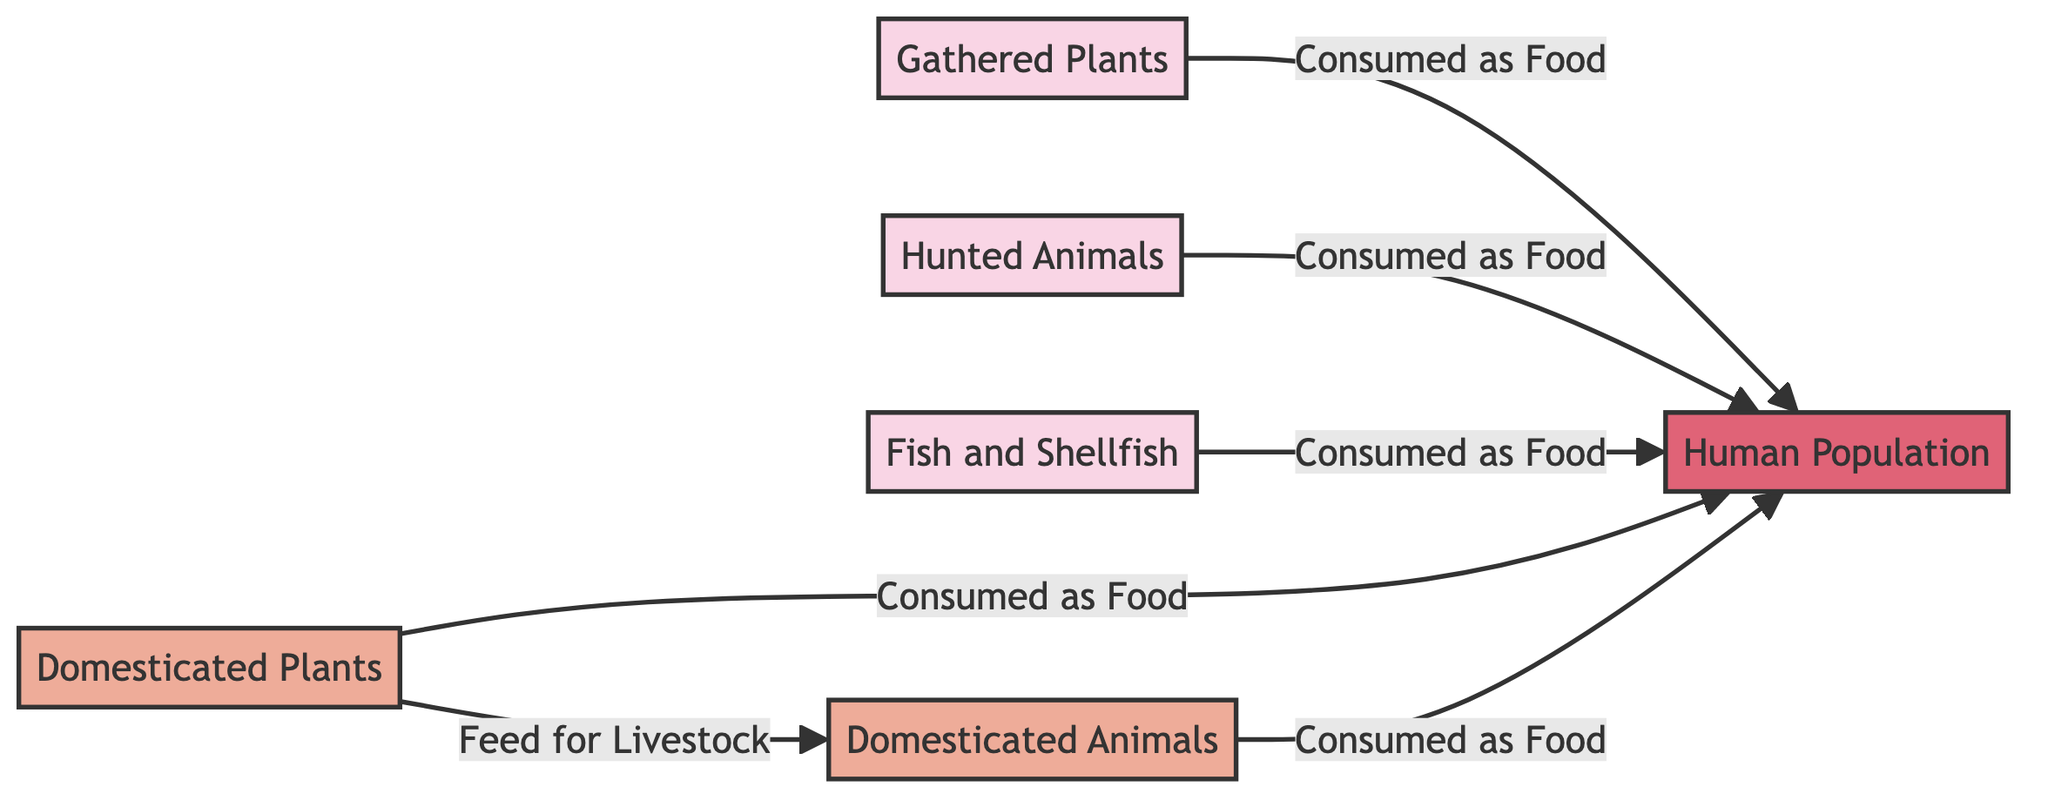What are the primary food sources for the human population? The diagram lists gathered plants, hunted animals, and fish and shellfish as the primary food sources. These are the nodes that directly feed into the human population node, indicating they are essential food sources for early humans.
Answer: gathered plants, hunted animals, fish and shellfish How many nodes are there in the diagram? The diagram has a total of six nodes: Gathered Plants, Hunted Animals, Fish and Shellfish, Domesticated Plants, Domesticated Animals, and Human Population. Each node represents a different aspect of the food chain in early human settlements.
Answer: 6 Which domesticated item is used as feed for livestock? The diagram indicates that domesticated plants serve as feed for domesticated animals, highlighting the relationship where domesticated plants contribute to the sustenance of livestock in agrarian societies.
Answer: Domesticated Plants What is the relationship between gathered plants and the human population? The relationship shown in the diagram is that gathered plants are consumed as food by the human population, highlighting how foraging contributed directly to the survival of early humans.
Answer: Consumed as Food What is the highest level in the food chain depicted in the diagram? The diagram portrays the human population as the top of the food chain, indicating that all other nodes provide food for this primary node, making it the apex predator of this early food system.
Answer: Human Population How many edges connect to the human population node? The human population node has five edges connecting to it: three from primary food sources (gathered plants, hunted animals, fish and shellfish) and two from secondary food sources (domesticated plants and domesticated animals). This indicates the diverse food intake of early humans.
Answer: 5 What color is used for the node representing hunted animals? In the diagram, hunted animals are represented in a light pinkish color, which distinguishes this category of food sources from others in the diagram.
Answer: #f9d5e5 What feeds into the domesticated animals node? The diagram shows that domesticated plants function as feed for domesticated animals, highlighting the connection between agricultural practices and livestock management.
Answer: Domesticated Plants How many relationships indicate the consumption of food by the human population? According to the diagram, there are five relationships indicating food consumption by the human population—one for each of the food sources (gathered plants, hunted animals, fish and shellfish, domesticated plants, and domesticated animals).
Answer: 5 